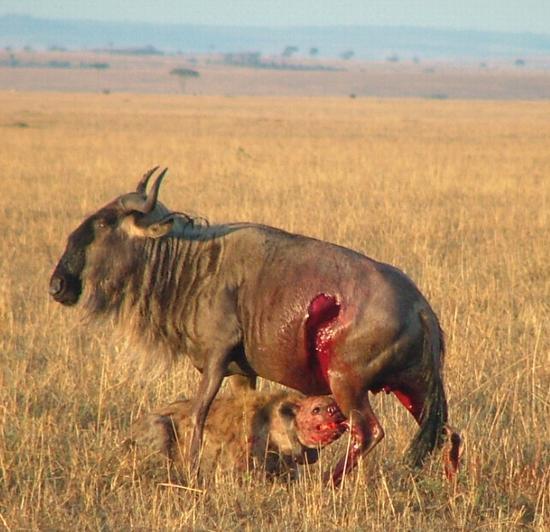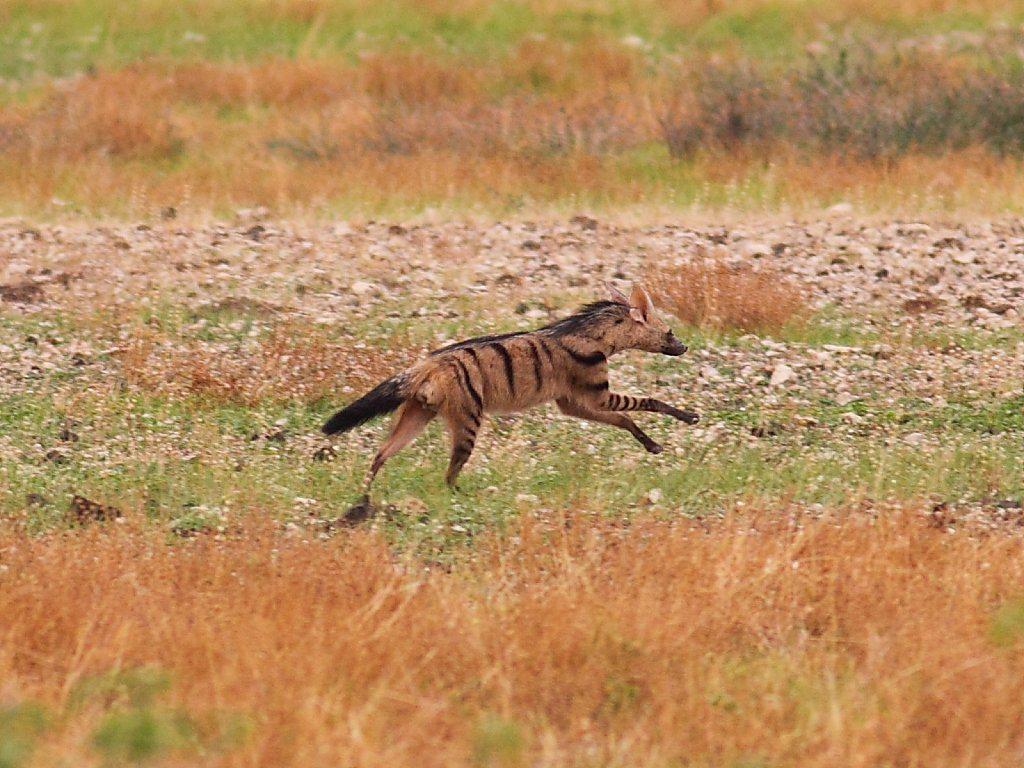The first image is the image on the left, the second image is the image on the right. Evaluate the accuracy of this statement regarding the images: "There are 1 or more hyena's attacking another animal.". Is it true? Answer yes or no. Yes. The first image is the image on the left, the second image is the image on the right. Considering the images on both sides, is "In the image to the left, at least one african_wild_dog faces off against a hyena." valid? Answer yes or no. No. 